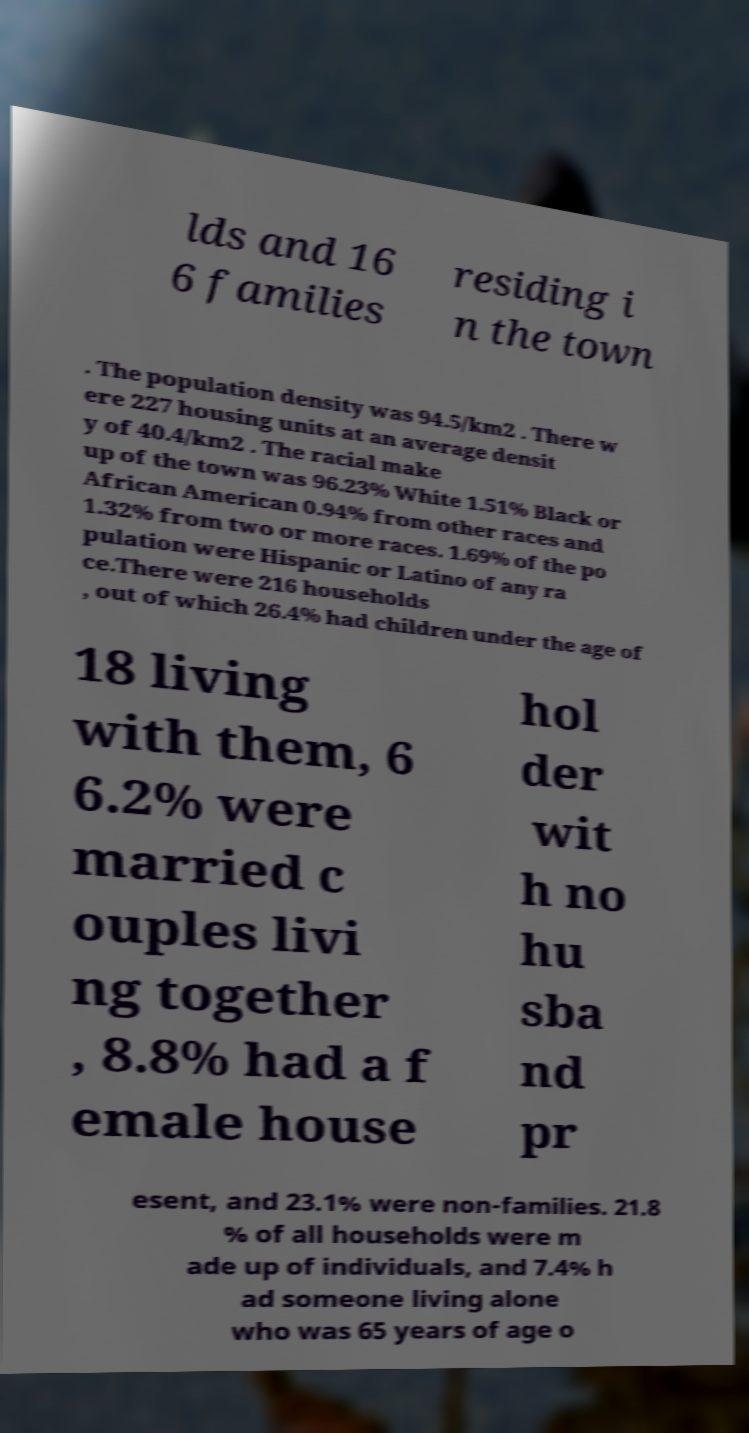Can you accurately transcribe the text from the provided image for me? lds and 16 6 families residing i n the town . The population density was 94.5/km2 . There w ere 227 housing units at an average densit y of 40.4/km2 . The racial make up of the town was 96.23% White 1.51% Black or African American 0.94% from other races and 1.32% from two or more races. 1.69% of the po pulation were Hispanic or Latino of any ra ce.There were 216 households , out of which 26.4% had children under the age of 18 living with them, 6 6.2% were married c ouples livi ng together , 8.8% had a f emale house hol der wit h no hu sba nd pr esent, and 23.1% were non-families. 21.8 % of all households were m ade up of individuals, and 7.4% h ad someone living alone who was 65 years of age o 